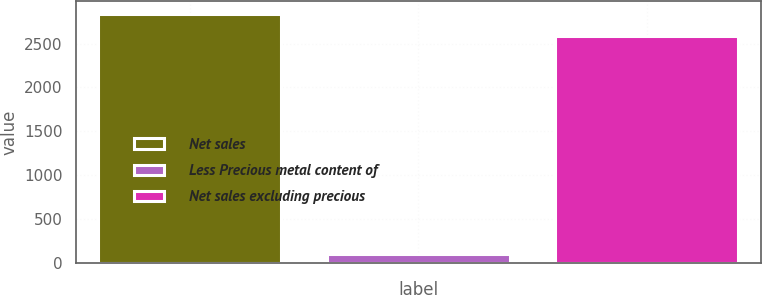Convert chart. <chart><loc_0><loc_0><loc_500><loc_500><bar_chart><fcel>Net sales<fcel>Less Precious metal content of<fcel>Net sales excluding precious<nl><fcel>2839.65<fcel>92.8<fcel>2581.5<nl></chart> 